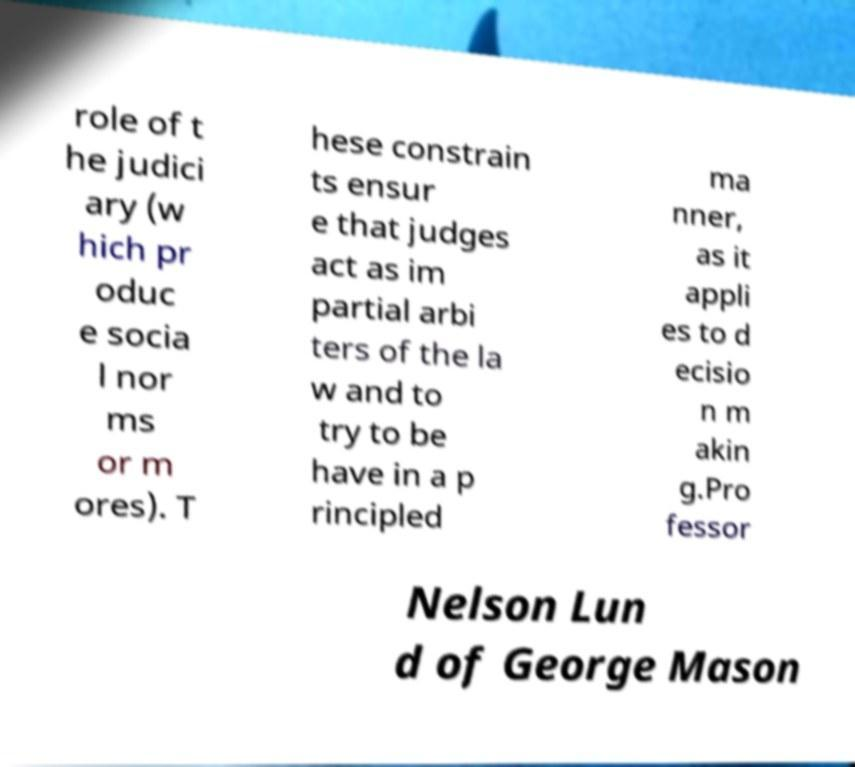For documentation purposes, I need the text within this image transcribed. Could you provide that? role of t he judici ary (w hich pr oduc e socia l nor ms or m ores). T hese constrain ts ensur e that judges act as im partial arbi ters of the la w and to try to be have in a p rincipled ma nner, as it appli es to d ecisio n m akin g.Pro fessor Nelson Lun d of George Mason 